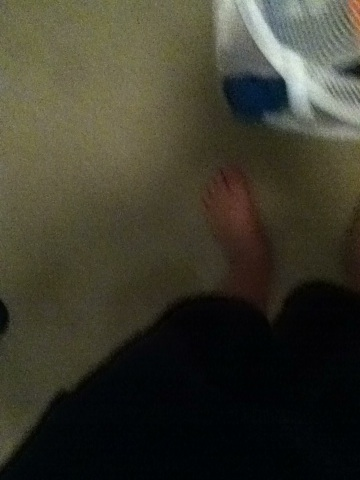Imagine if this basket had a magical property. What could it be? Imagine if the basket had the magical ability to automatically sort, wash, and fold clothes. You could place dirty clothes in it, and within moments, they would be clean, dried, and neatly folded. This basket could have made mundane laundry tasks obsolete and freed up time for more enjoyable activities! 